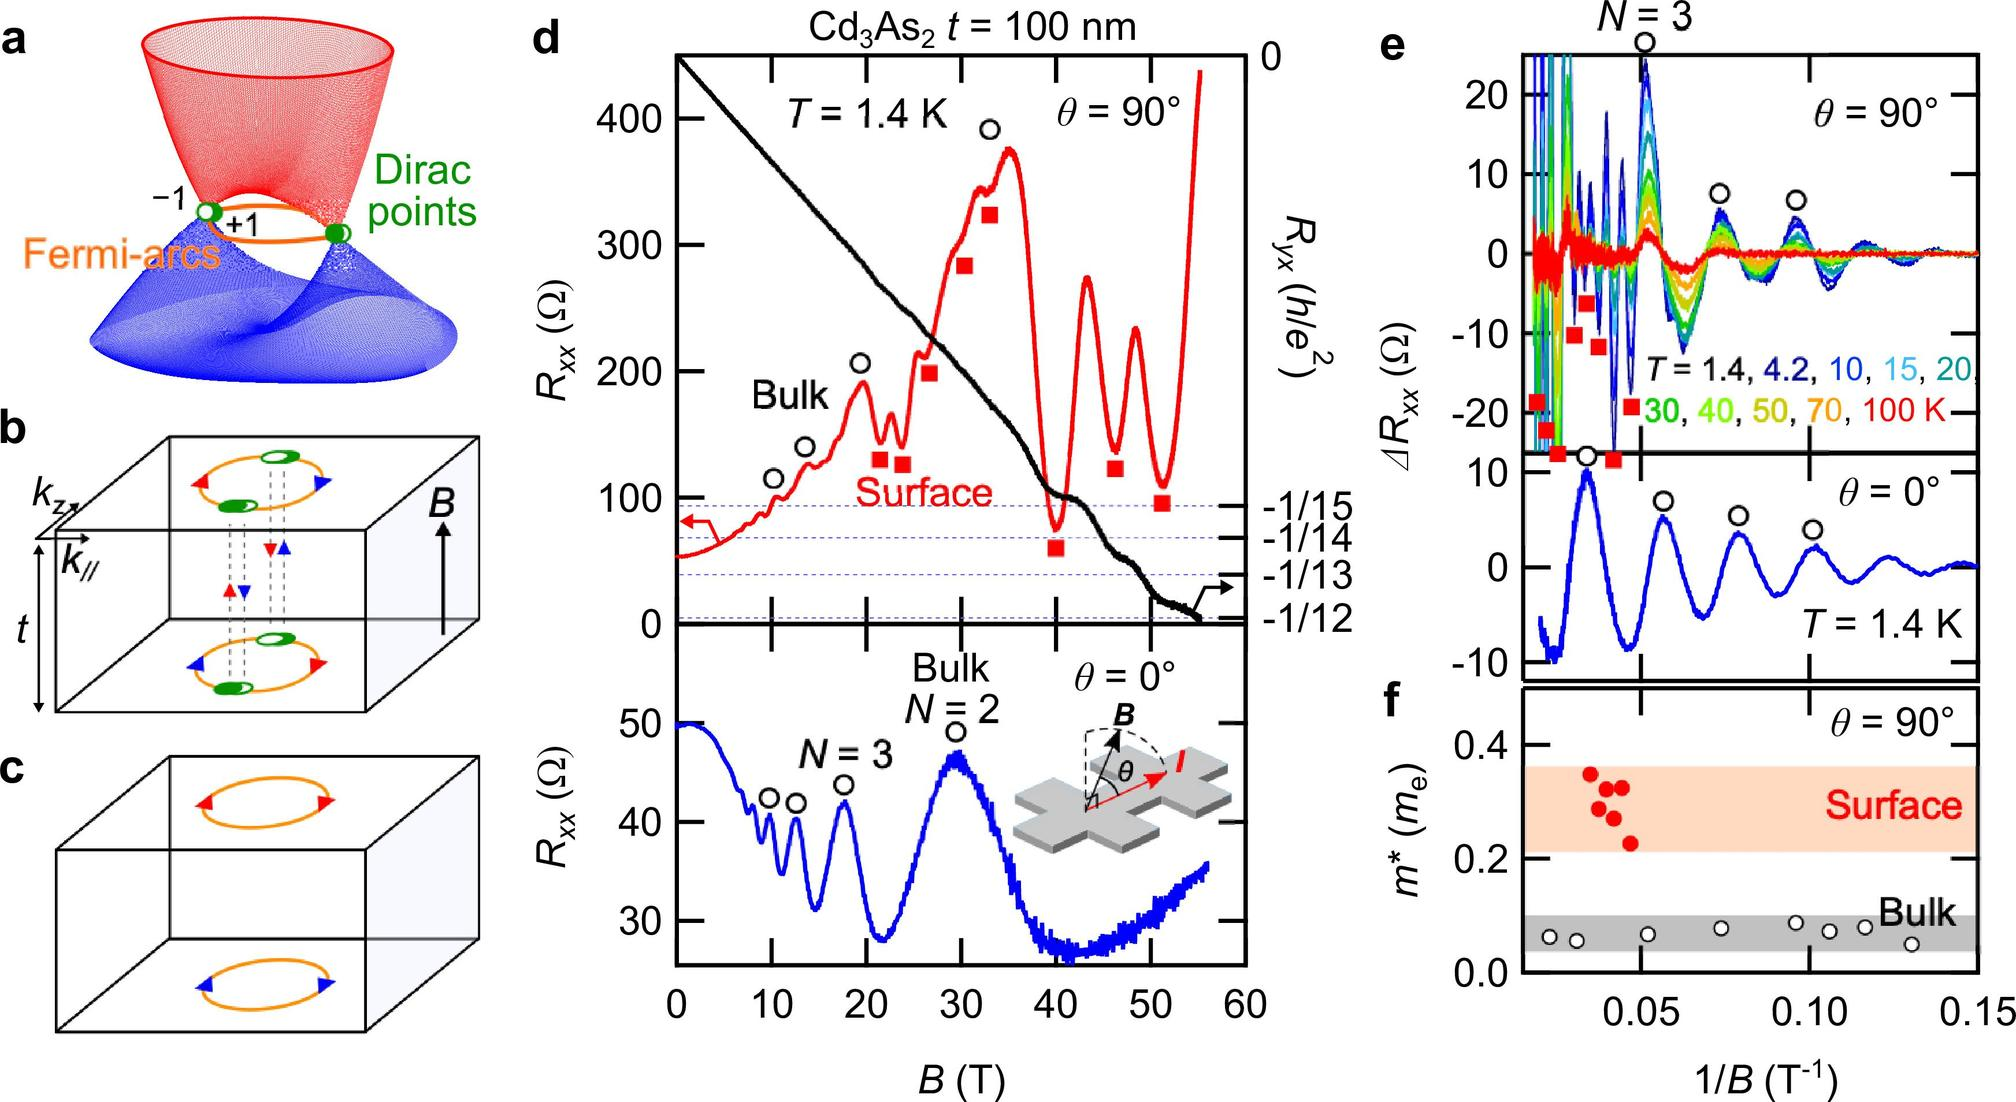Can you explain how the shape of the Fermi-arcs in panel a might affect conductivity? The Fermi-arcs depicted in panel a illustrate the surface connections between Dirac points at different energy states. Their unique shape affects conductivity by providing paths for surface electrons. The arcs' curvature and openness might enable high mobility for surface charge carriers, significantly influencing the material's overall conductivity, particularly under varying magnetic fields. 